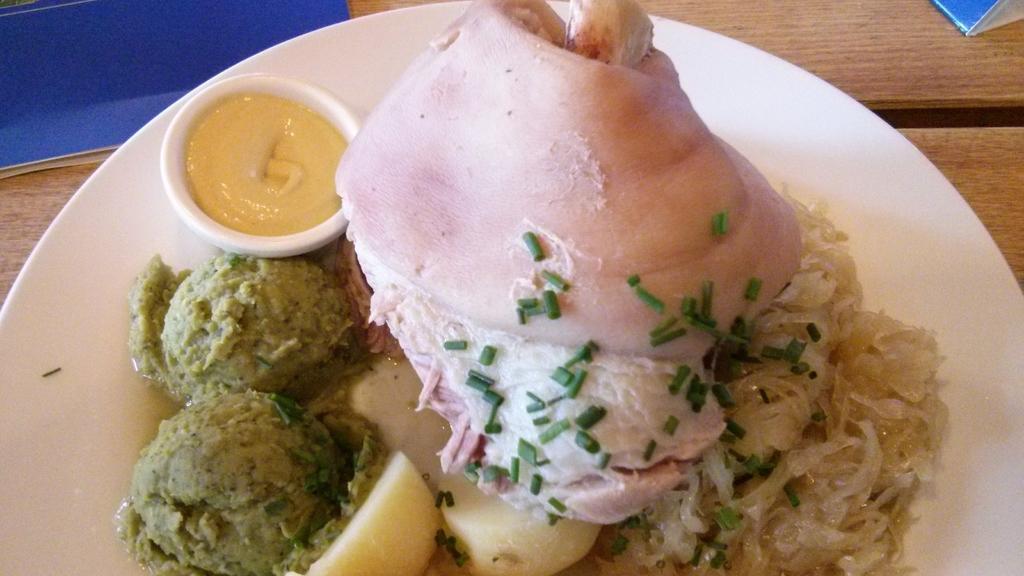Can you describe this image briefly? In this image I can see food items in a plate and also a bowl filled with sauce may be kept on a table and some objects. This image is taken, may be in a hotel. 